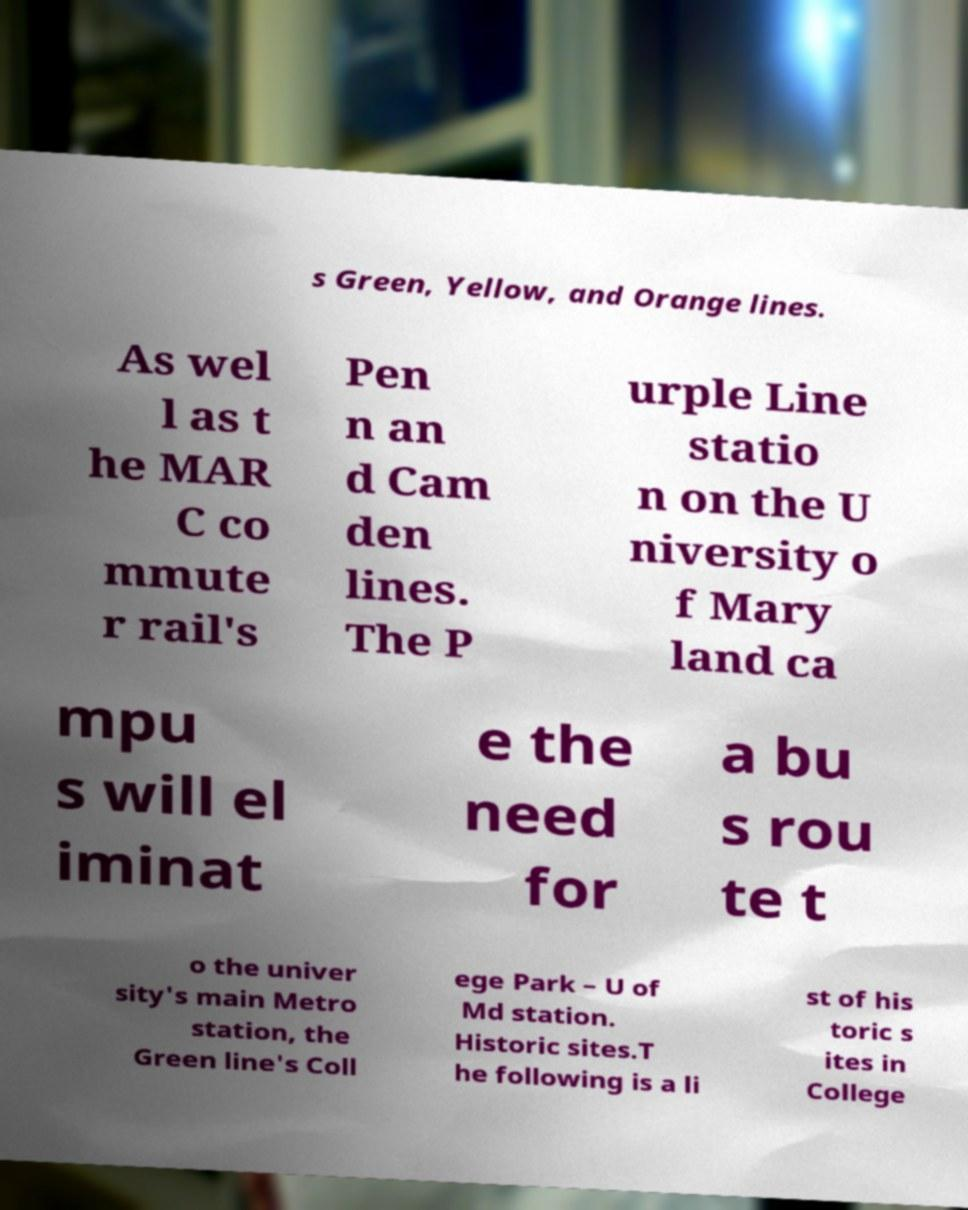Please read and relay the text visible in this image. What does it say? s Green, Yellow, and Orange lines. As wel l as t he MAR C co mmute r rail's Pen n an d Cam den lines. The P urple Line statio n on the U niversity o f Mary land ca mpu s will el iminat e the need for a bu s rou te t o the univer sity's main Metro station, the Green line's Coll ege Park – U of Md station. Historic sites.T he following is a li st of his toric s ites in College 